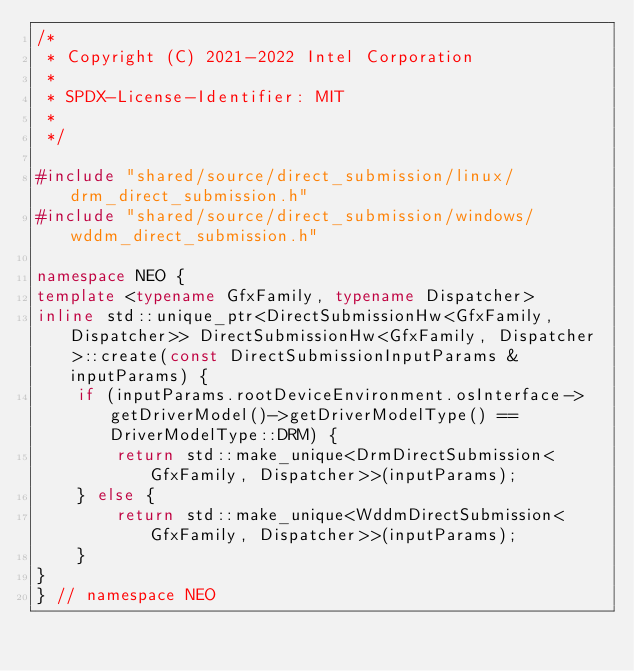Convert code to text. <code><loc_0><loc_0><loc_500><loc_500><_C++_>/*
 * Copyright (C) 2021-2022 Intel Corporation
 *
 * SPDX-License-Identifier: MIT
 *
 */

#include "shared/source/direct_submission/linux/drm_direct_submission.h"
#include "shared/source/direct_submission/windows/wddm_direct_submission.h"

namespace NEO {
template <typename GfxFamily, typename Dispatcher>
inline std::unique_ptr<DirectSubmissionHw<GfxFamily, Dispatcher>> DirectSubmissionHw<GfxFamily, Dispatcher>::create(const DirectSubmissionInputParams &inputParams) {
    if (inputParams.rootDeviceEnvironment.osInterface->getDriverModel()->getDriverModelType() == DriverModelType::DRM) {
        return std::make_unique<DrmDirectSubmission<GfxFamily, Dispatcher>>(inputParams);
    } else {
        return std::make_unique<WddmDirectSubmission<GfxFamily, Dispatcher>>(inputParams);
    }
}
} // namespace NEO
</code> 